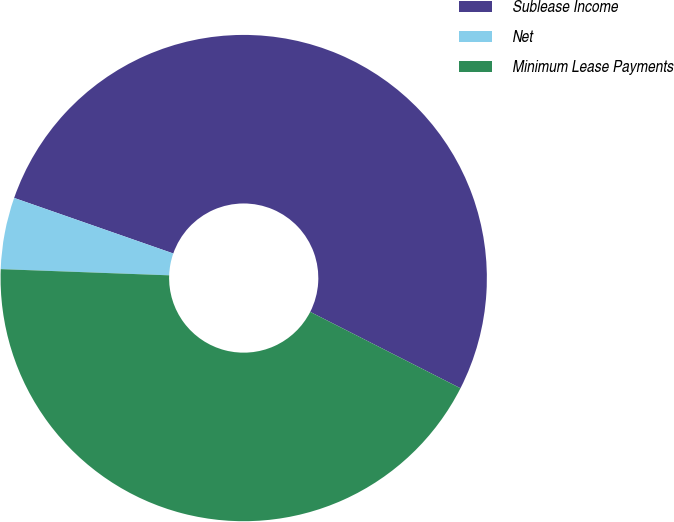Convert chart to OTSL. <chart><loc_0><loc_0><loc_500><loc_500><pie_chart><fcel>Sublease Income<fcel>Net<fcel>Minimum Lease Payments<nl><fcel>52.14%<fcel>4.76%<fcel>43.1%<nl></chart> 